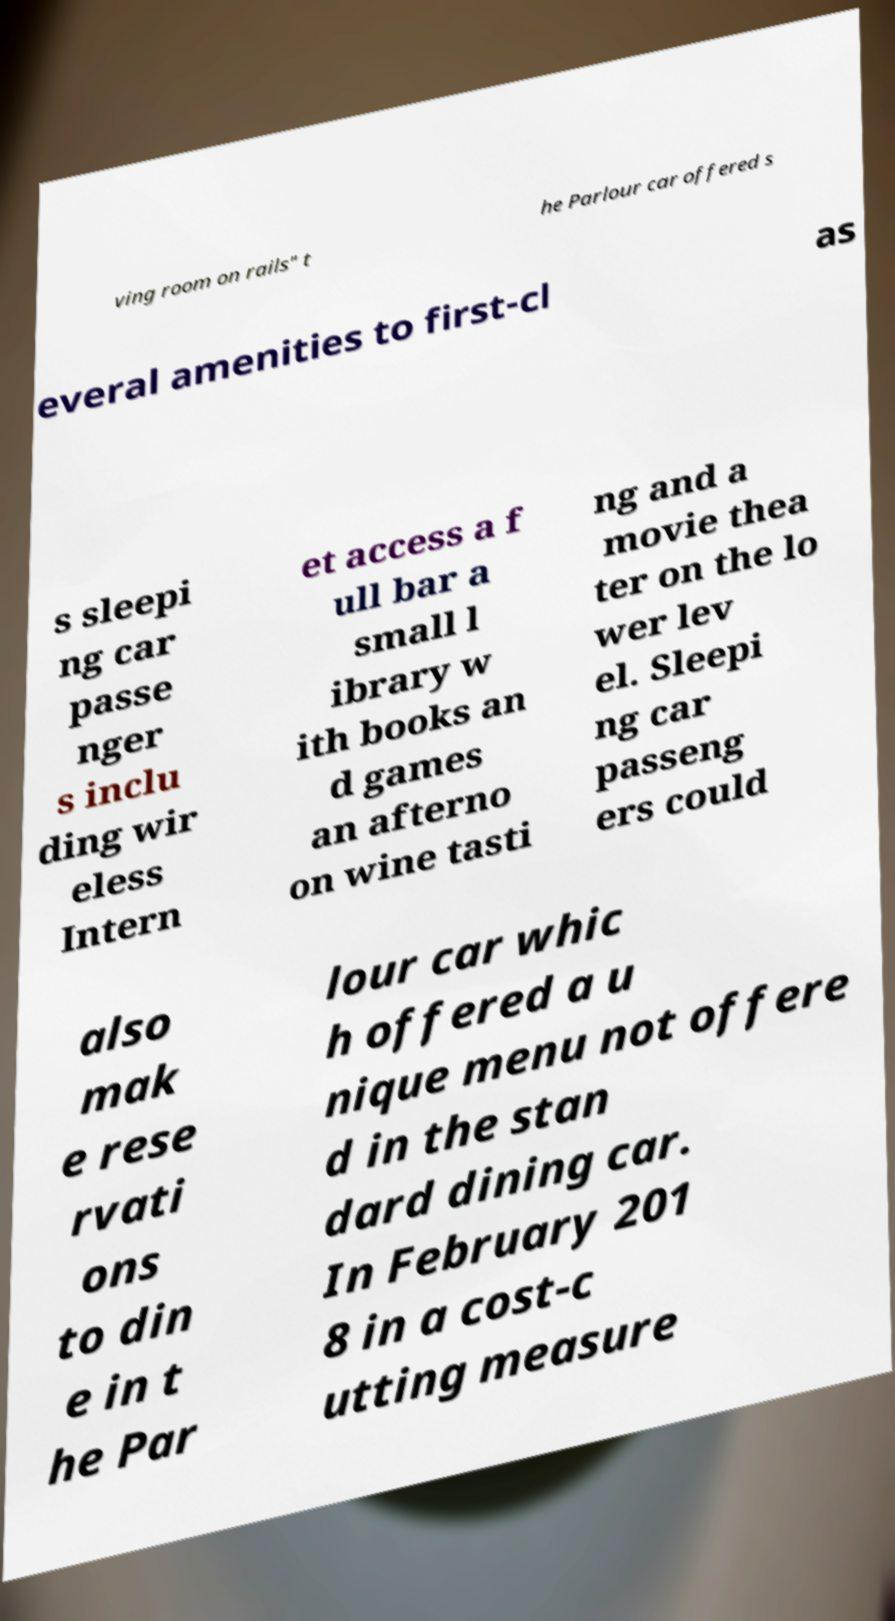Can you read and provide the text displayed in the image?This photo seems to have some interesting text. Can you extract and type it out for me? ving room on rails" t he Parlour car offered s everal amenities to first-cl as s sleepi ng car passe nger s inclu ding wir eless Intern et access a f ull bar a small l ibrary w ith books an d games an afterno on wine tasti ng and a movie thea ter on the lo wer lev el. Sleepi ng car passeng ers could also mak e rese rvati ons to din e in t he Par lour car whic h offered a u nique menu not offere d in the stan dard dining car. In February 201 8 in a cost-c utting measure 